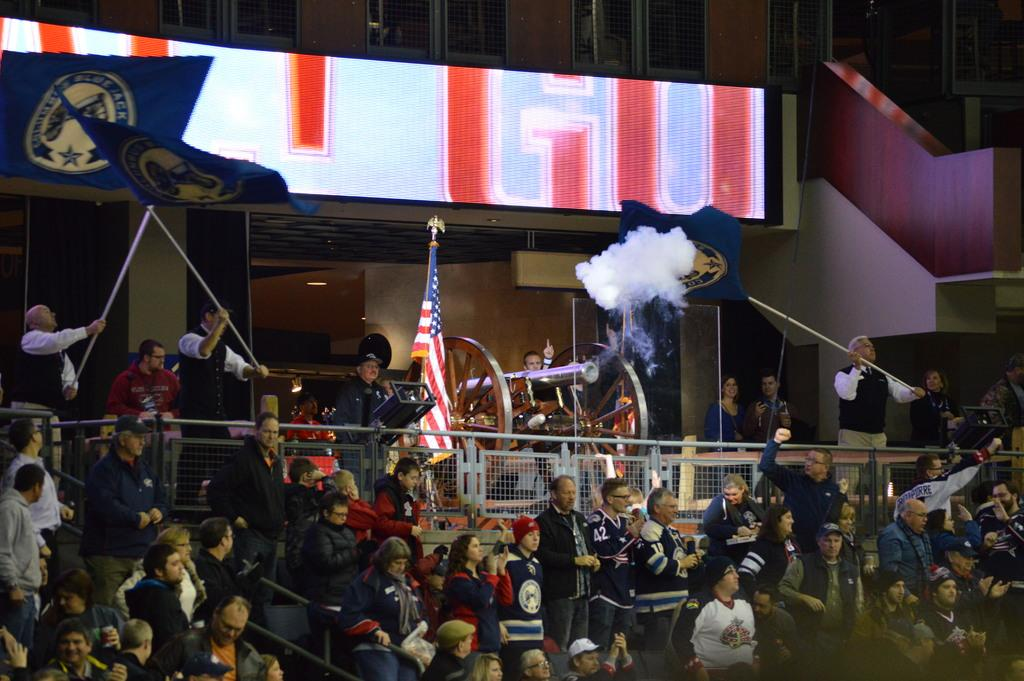What can be seen in the image? There are people, railings, a cannon, smoke, flags, a board, a building, and a wall in the image. What might the people be doing in the image? The presence of railings, a cannon, and smoke suggests that the people might be at a historical site or a military installation. What is the background of the image like? The background of the image includes a board, a building, and a wall. Are there any symbols or markers in the image? Yes, there are flags in the image. What type of degree is the chicken holding in the image? There is no chicken present in the image, and therefore no degree can be observed. 